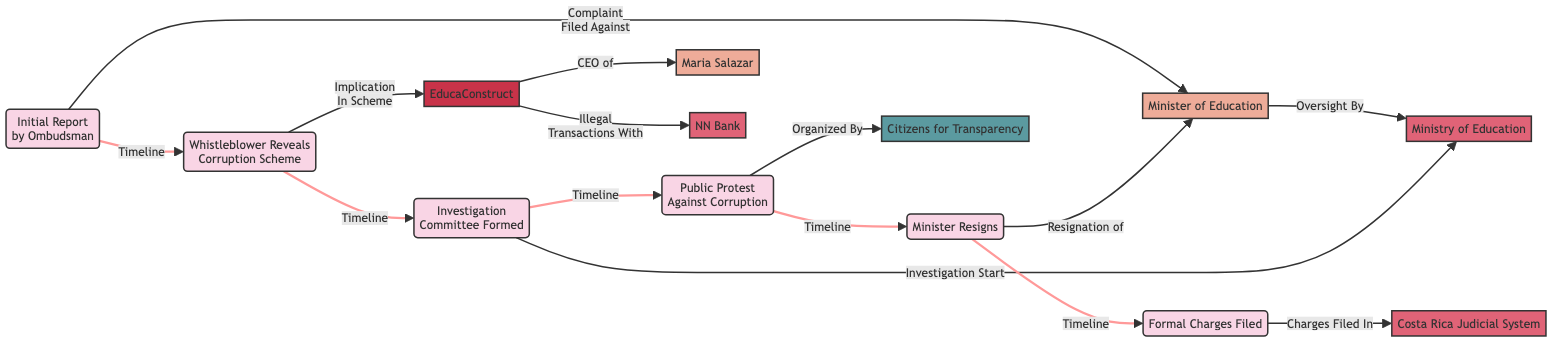What is the first event in the timeline? The timeline starts with the event “Initial Report by Ombudsman” which is marked with the date 20170310.
Answer: Initial Report by Ombudsman Who is the CEO of EducaConstruct? The diagram indicates that “Maria Salazar” is associated as the "CEO of" EducaConstruct through a direct relationship.
Answer: Maria Salazar Which organization organized the public protest against corruption? The event “Public Protest Against Corruption” on 20180114 shows a directed edge to “Citizens for Transparency,” indicating that they organized the protest.
Answer: Citizens for Transparency How many events are depicted in the timeline? By counting the nodes labeled as events, there are six distinct events in the timeline: Initial Report, Whistleblower Reveal, Investigation Committee Formed, Public Protest, Minister Resigns, and Formal Charges Filed.
Answer: 6 What is the relationship between the Minister of Education and the Ministry of Education? The directed edge between “Minister of Education” and “Ministry of Education” indicates an “Oversight By” relationship, showing the Minister's role in overseeing the Ministry.
Answer: Oversight By What triggered the investigation in the Ministry of Education? The edge from the event “Investigation Committee Formed” on 20170922 to the “Ministry of Education” states that this event initiated the investigation related to the corruption case.
Answer: Investigation Start How many entities are involved in the diagram? There are three entities listed in the diagram: “Ministry of Education,” “NN Bank,” and “Costa Rica Judicial System,” making for a total of three distinct entities.
Answer: 3 What is the last event recorded in the timeline? The last event in the timeline is “Formal Charges Filed” marked with the date 20180610, indicating the culmination of the events in this corruption case timeline.
Answer: Formal Charges Filed What company is implicated in the corruption scheme? The edge from the event “Whistleblower Reveals Corruption Scheme” on 20170515 points towards “EducaConstruct” indicating its implication in the corruption scheme.
Answer: EducaConstruct 